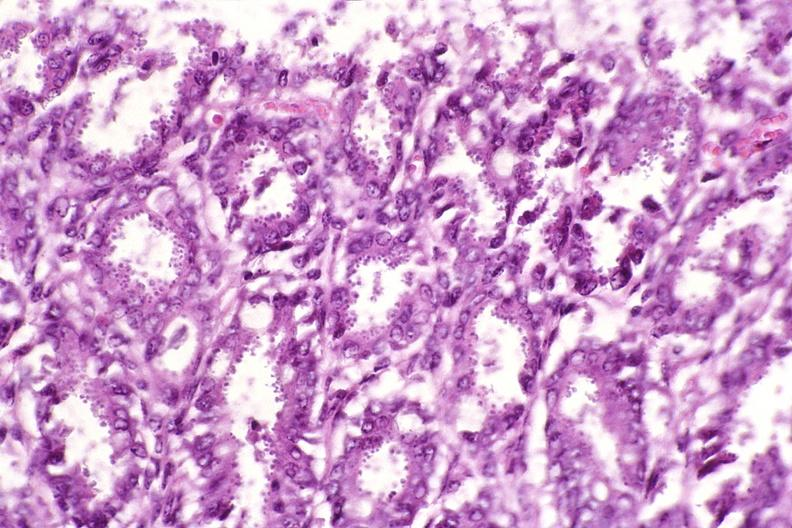s yo present?
Answer the question using a single word or phrase. No 